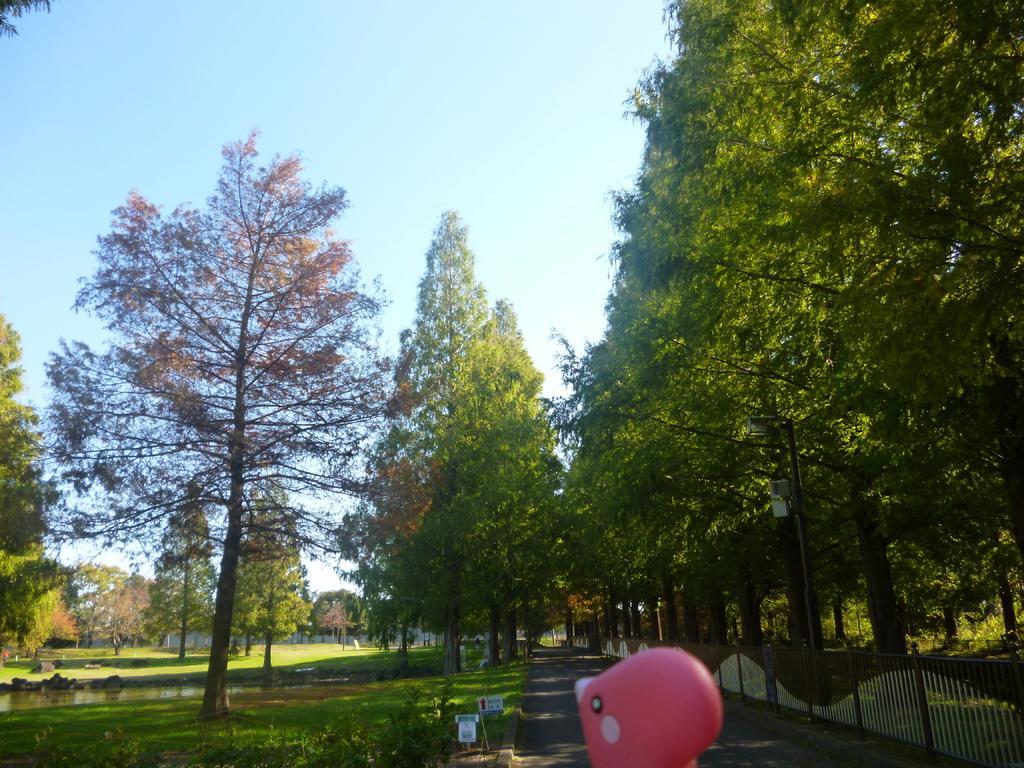Please provide a concise description of this image. On the right side of the image we can see trees, poles, fencing and roads. On the left side of the image we can see trees, water and grass. In the background there is sky. 